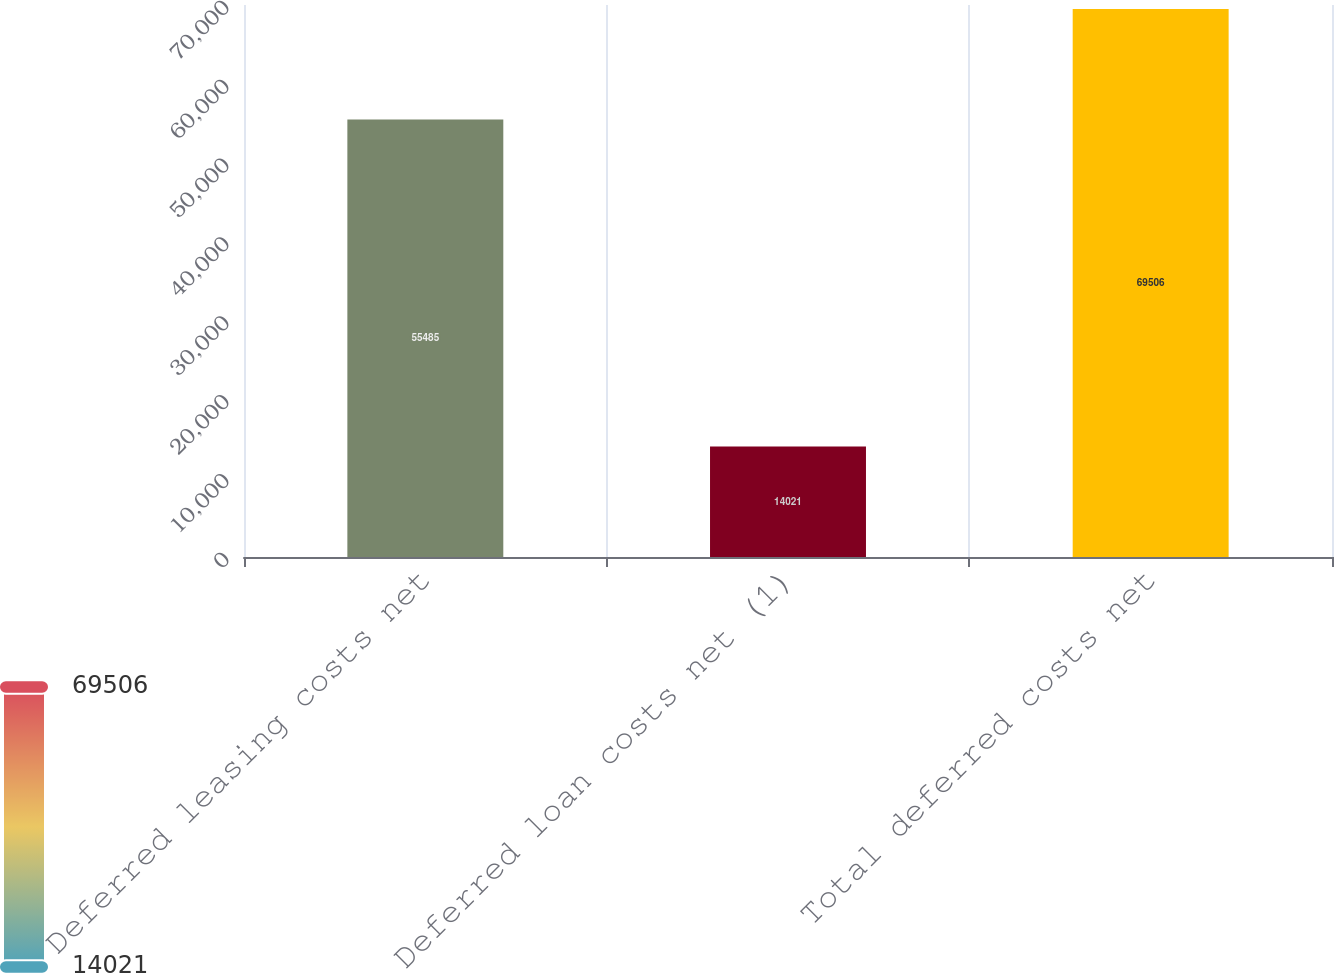<chart> <loc_0><loc_0><loc_500><loc_500><bar_chart><fcel>Deferred leasing costs net<fcel>Deferred loan costs net (1)<fcel>Total deferred costs net<nl><fcel>55485<fcel>14021<fcel>69506<nl></chart> 